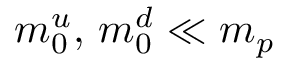Convert formula to latex. <formula><loc_0><loc_0><loc_500><loc_500>m _ { 0 } ^ { u } , \, m _ { 0 } ^ { d } \ll m _ { p }</formula> 